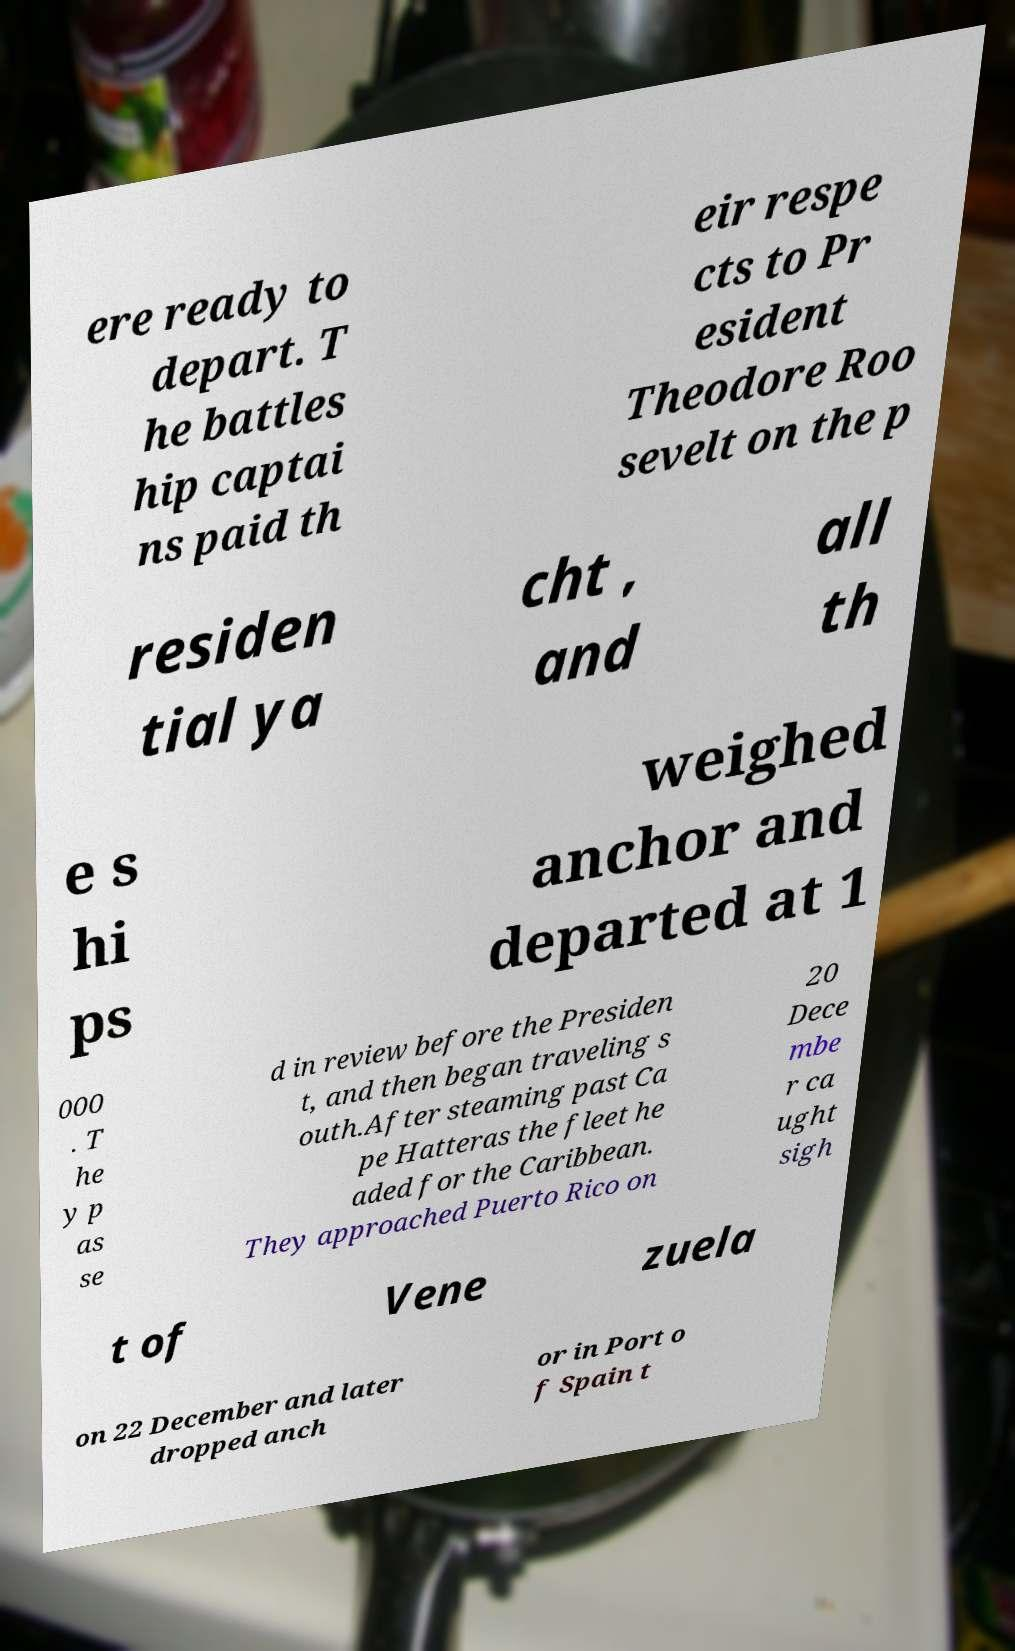Please read and relay the text visible in this image. What does it say? ere ready to depart. T he battles hip captai ns paid th eir respe cts to Pr esident Theodore Roo sevelt on the p residen tial ya cht , and all th e s hi ps weighed anchor and departed at 1 000 . T he y p as se d in review before the Presiden t, and then began traveling s outh.After steaming past Ca pe Hatteras the fleet he aded for the Caribbean. They approached Puerto Rico on 20 Dece mbe r ca ught sigh t of Vene zuela on 22 December and later dropped anch or in Port o f Spain t 